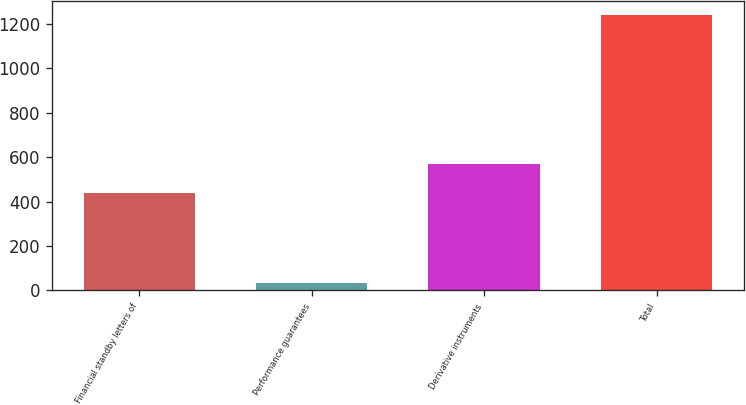<chart> <loc_0><loc_0><loc_500><loc_500><bar_chart><fcel>Financial standby letters of<fcel>Performance guarantees<fcel>Derivative instruments<fcel>Total<nl><fcel>438.8<fcel>32.4<fcel>569.2<fcel>1238.4<nl></chart> 